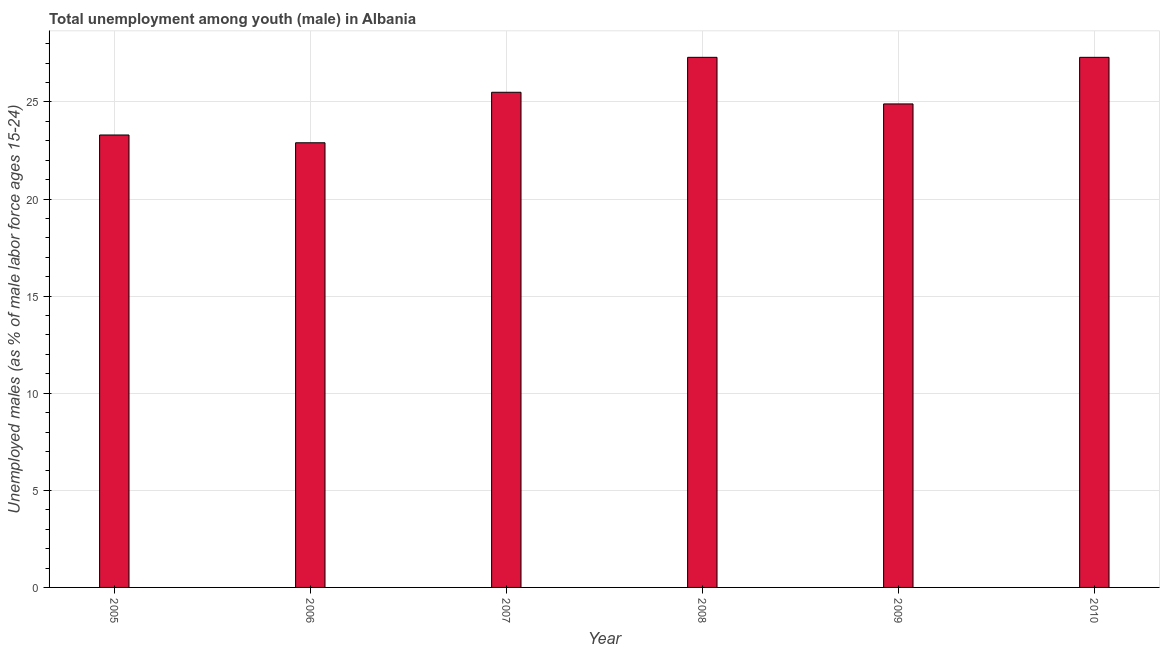What is the title of the graph?
Offer a very short reply. Total unemployment among youth (male) in Albania. What is the label or title of the X-axis?
Offer a terse response. Year. What is the label or title of the Y-axis?
Keep it short and to the point. Unemployed males (as % of male labor force ages 15-24). What is the unemployed male youth population in 2006?
Ensure brevity in your answer.  22.9. Across all years, what is the maximum unemployed male youth population?
Give a very brief answer. 27.3. Across all years, what is the minimum unemployed male youth population?
Give a very brief answer. 22.9. In which year was the unemployed male youth population maximum?
Offer a terse response. 2008. What is the sum of the unemployed male youth population?
Keep it short and to the point. 151.2. What is the difference between the unemployed male youth population in 2005 and 2007?
Ensure brevity in your answer.  -2.2. What is the average unemployed male youth population per year?
Provide a succinct answer. 25.2. What is the median unemployed male youth population?
Offer a very short reply. 25.2. Do a majority of the years between 2009 and 2007 (inclusive) have unemployed male youth population greater than 10 %?
Offer a very short reply. Yes. What is the ratio of the unemployed male youth population in 2006 to that in 2010?
Provide a succinct answer. 0.84. How many bars are there?
Provide a succinct answer. 6. Are all the bars in the graph horizontal?
Offer a very short reply. No. How many years are there in the graph?
Your answer should be compact. 6. What is the Unemployed males (as % of male labor force ages 15-24) in 2005?
Your answer should be very brief. 23.3. What is the Unemployed males (as % of male labor force ages 15-24) in 2006?
Offer a very short reply. 22.9. What is the Unemployed males (as % of male labor force ages 15-24) in 2008?
Make the answer very short. 27.3. What is the Unemployed males (as % of male labor force ages 15-24) in 2009?
Your answer should be compact. 24.9. What is the Unemployed males (as % of male labor force ages 15-24) of 2010?
Keep it short and to the point. 27.3. What is the difference between the Unemployed males (as % of male labor force ages 15-24) in 2005 and 2009?
Your answer should be compact. -1.6. What is the difference between the Unemployed males (as % of male labor force ages 15-24) in 2005 and 2010?
Offer a very short reply. -4. What is the difference between the Unemployed males (as % of male labor force ages 15-24) in 2006 and 2010?
Offer a terse response. -4.4. What is the difference between the Unemployed males (as % of male labor force ages 15-24) in 2007 and 2008?
Keep it short and to the point. -1.8. What is the difference between the Unemployed males (as % of male labor force ages 15-24) in 2007 and 2010?
Ensure brevity in your answer.  -1.8. What is the ratio of the Unemployed males (as % of male labor force ages 15-24) in 2005 to that in 2006?
Your answer should be compact. 1.02. What is the ratio of the Unemployed males (as % of male labor force ages 15-24) in 2005 to that in 2007?
Provide a short and direct response. 0.91. What is the ratio of the Unemployed males (as % of male labor force ages 15-24) in 2005 to that in 2008?
Your response must be concise. 0.85. What is the ratio of the Unemployed males (as % of male labor force ages 15-24) in 2005 to that in 2009?
Your answer should be very brief. 0.94. What is the ratio of the Unemployed males (as % of male labor force ages 15-24) in 2005 to that in 2010?
Offer a very short reply. 0.85. What is the ratio of the Unemployed males (as % of male labor force ages 15-24) in 2006 to that in 2007?
Your answer should be compact. 0.9. What is the ratio of the Unemployed males (as % of male labor force ages 15-24) in 2006 to that in 2008?
Your response must be concise. 0.84. What is the ratio of the Unemployed males (as % of male labor force ages 15-24) in 2006 to that in 2009?
Provide a short and direct response. 0.92. What is the ratio of the Unemployed males (as % of male labor force ages 15-24) in 2006 to that in 2010?
Ensure brevity in your answer.  0.84. What is the ratio of the Unemployed males (as % of male labor force ages 15-24) in 2007 to that in 2008?
Keep it short and to the point. 0.93. What is the ratio of the Unemployed males (as % of male labor force ages 15-24) in 2007 to that in 2010?
Ensure brevity in your answer.  0.93. What is the ratio of the Unemployed males (as % of male labor force ages 15-24) in 2008 to that in 2009?
Keep it short and to the point. 1.1. What is the ratio of the Unemployed males (as % of male labor force ages 15-24) in 2009 to that in 2010?
Offer a very short reply. 0.91. 